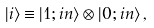Convert formula to latex. <formula><loc_0><loc_0><loc_500><loc_500>| i \rangle \equiv | 1 ; i n \rangle \otimes | 0 ; i n \rangle \, ,</formula> 